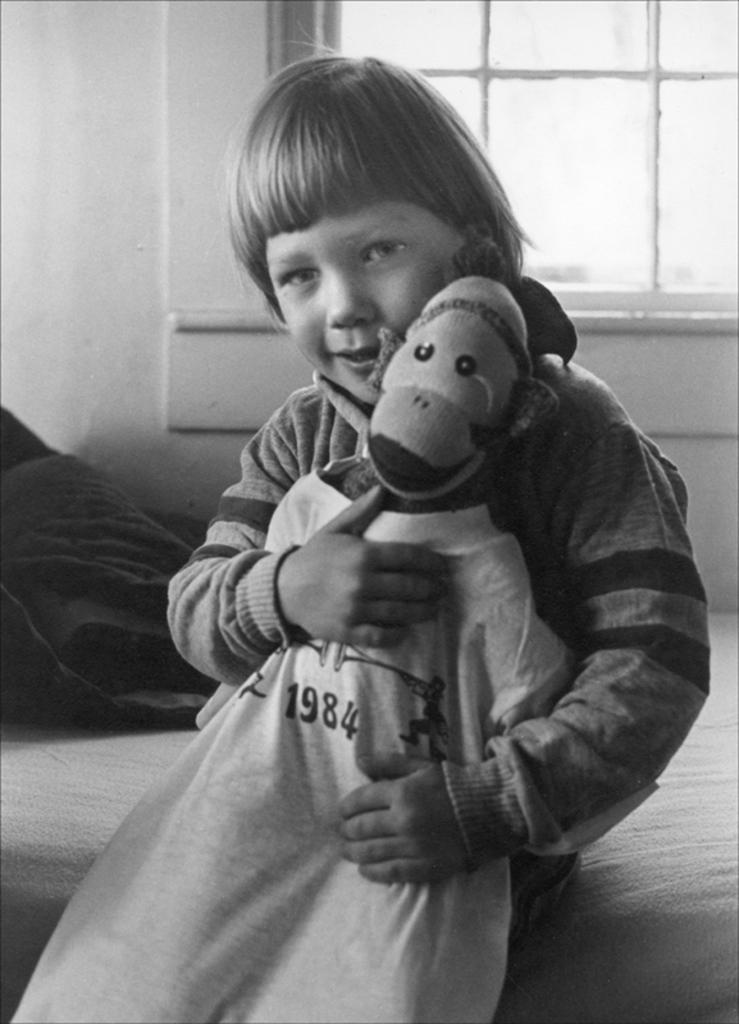What is the color scheme of the image? The image is black and white. Who or what is the main subject in the image? There is a kid in the image. What is the kid interacting with in the image? There is a toy in the image. What can be seen in the background of the image? There is a wall, a glass window, and other objects visible in the background of the image. Can you tell me how many pigs are fighting in the image? There are no pigs or fighting depicted in the image; it features a kid with a toy in a black and white setting. 